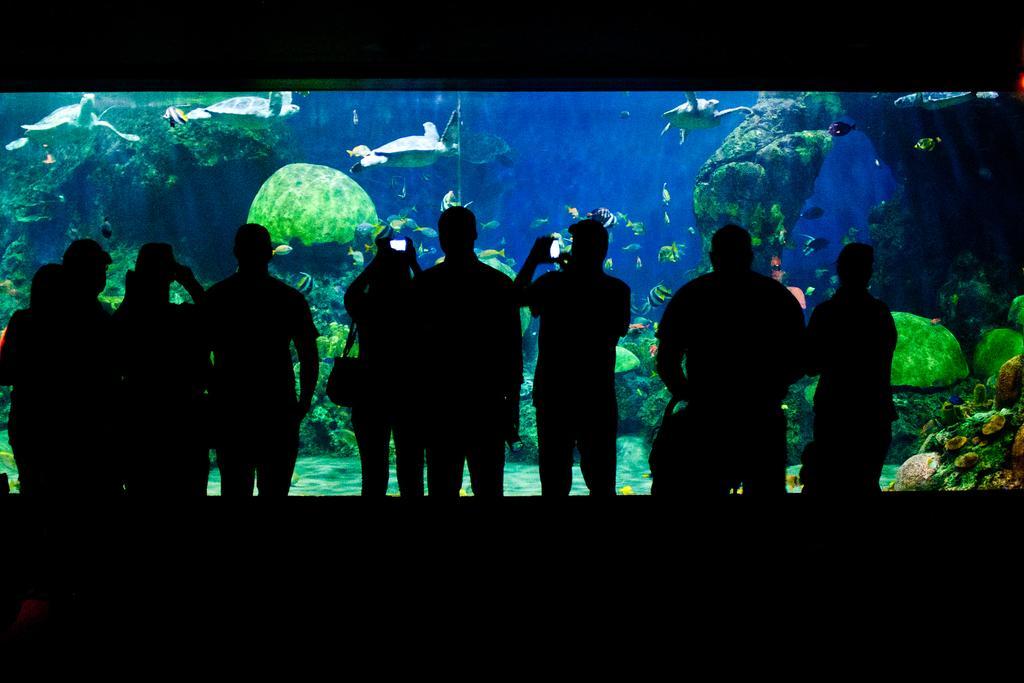Please provide a concise description of this image. This image consists of few persons standing. In the front, there is an aquarium. In which we can see the turtles and fishes along with the plants. 